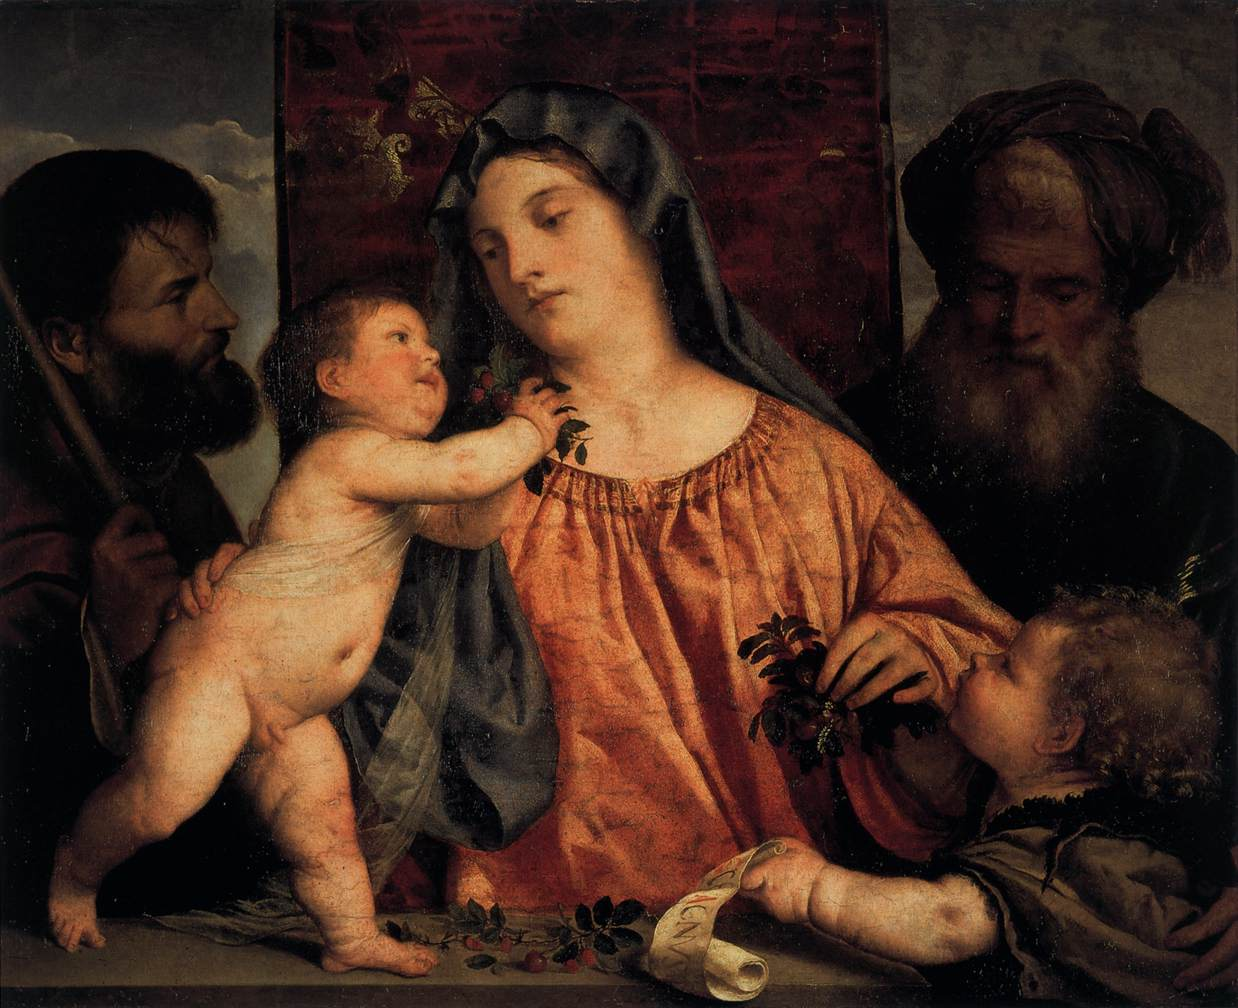Write a detailed description of the given image. The image presented is a classic example of Renaissance art, depicting the Holy Family with Saint Joseph on the left and an elderly figure, likely representing Saint Anne or a prophet, on the right. In the center, the Virgin Mary, garbed in a rich orange dress and a bluish veil, cradles the infant Jesus who reaches to touch her face affectionately. To her right, a young John the Baptist, identifiable by his rustic attire and the reed cross he holds, offers Jesus some berries in a moment of tender interaction. The painting masterfully captures the interplay of gazes and gestures that convey a warmth and intimacy among the figures, set against a muted landscape backdrop and a draped curtain to the right, elements that lend depth and context to the sacred scene. 